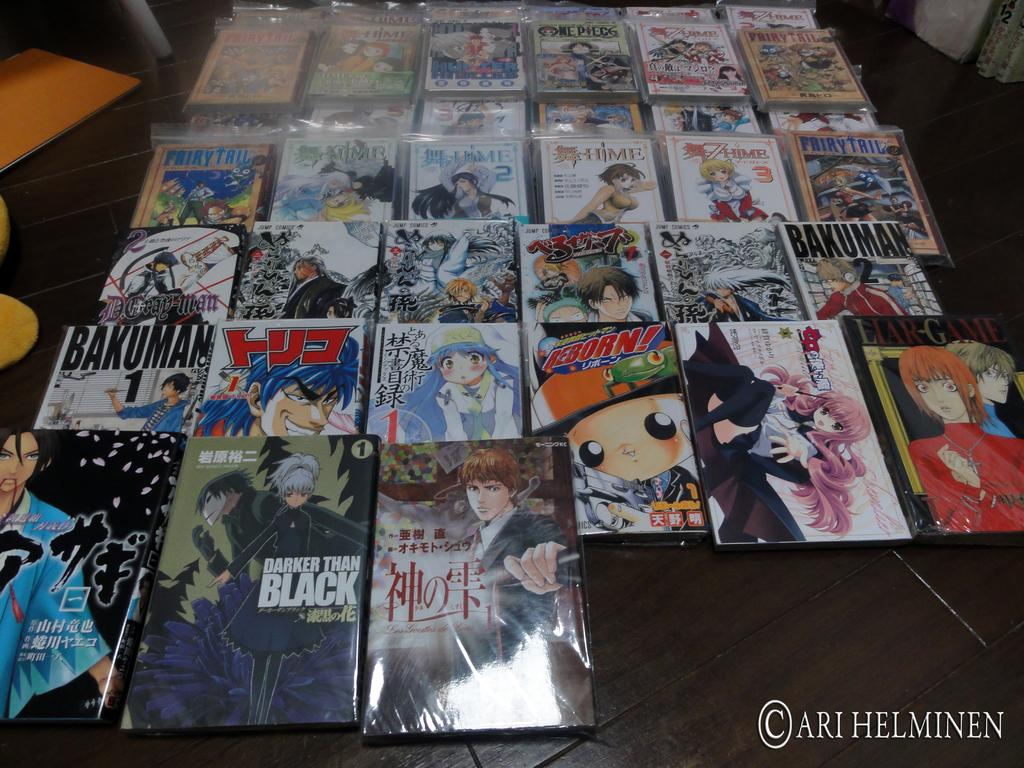What type of reading material is on the floor in the image? There are comic books on the floor. What can be seen behind the comic books? There are objects behind the comic books. Can you describe any additional features of the image? Yes, there is a watermark on the image. What type of leather is visible on the comic books in the image? There is no leather visible on the comic books in the image. How can the direction of the comic books be adjusted in the image? The direction of the comic books cannot be adjusted in the image, as it is a static photograph. 